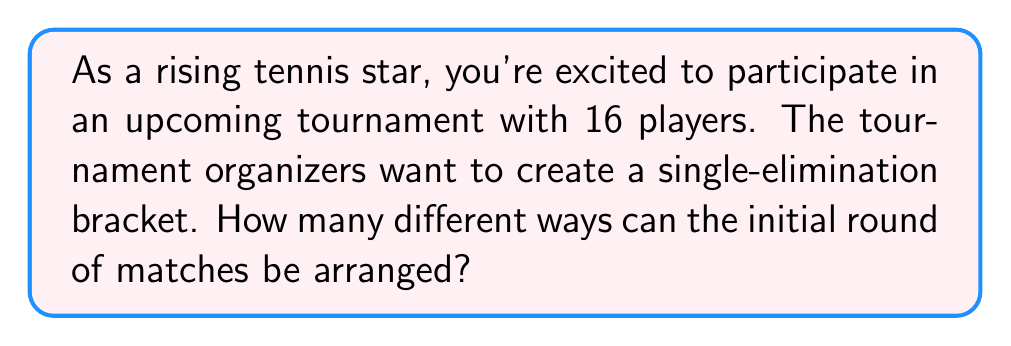Could you help me with this problem? Let's approach this step-by-step:

1) In a single-elimination tournament with 16 players, there will be 8 initial matches.

2) We need to determine how many ways we can pair up 16 players into 8 matches.

3) This is equivalent to choosing 8 pairs from 16 players, where the order of pairs matters (as it determines the bracket structure), but the order within each pair doesn't matter.

4) We can solve this using the following process:
   a) Choose 2 players for the first match: $\binom{16}{2}$ ways
   b) Choose 2 players for the second match from the remaining 14: $\binom{14}{2}$ ways
   c) Continue this process until all 8 matches are set

5) The total number of ways to arrange the matches is therefore:

   $$\binom{16}{2} \cdot \binom{14}{2} \cdot \binom{12}{2} \cdot \binom{10}{2} \cdot \binom{8}{2} \cdot \binom{6}{2} \cdot \binom{4}{2} \cdot \binom{2}{2}$$

6) Let's calculate this:
   $$\frac{16!}{2!(16-2)!} \cdot \frac{14!}{2!(14-2)!} \cdot \frac{12!}{2!(12-2)!} \cdot \frac{10!}{2!(10-2)!} \cdot \frac{8!}{2!(8-2)!} \cdot \frac{6!}{2!(6-2)!} \cdot \frac{4!}{2!(4-2)!} \cdot \frac{2!}{2!(2-2)!}$$

7) Simplifying:
   $$120 \cdot 91 \cdot 66 \cdot 45 \cdot 28 \cdot 15 \cdot 6 \cdot 1 = 2,027,025,600$$

Thus, there are 2,027,025,600 different ways to arrange the initial round of matches.
Answer: 2,027,025,600 